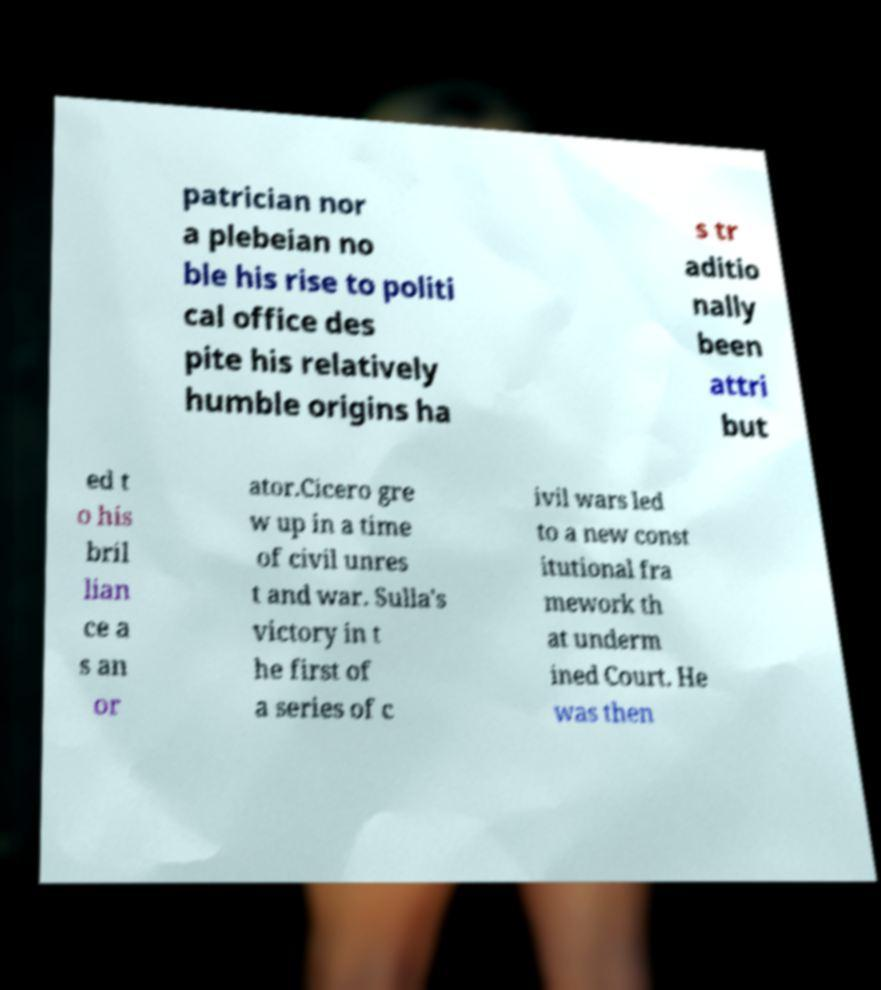Please read and relay the text visible in this image. What does it say? patrician nor a plebeian no ble his rise to politi cal office des pite his relatively humble origins ha s tr aditio nally been attri but ed t o his bril lian ce a s an or ator.Cicero gre w up in a time of civil unres t and war. Sulla's victory in t he first of a series of c ivil wars led to a new const itutional fra mework th at underm ined Court. He was then 